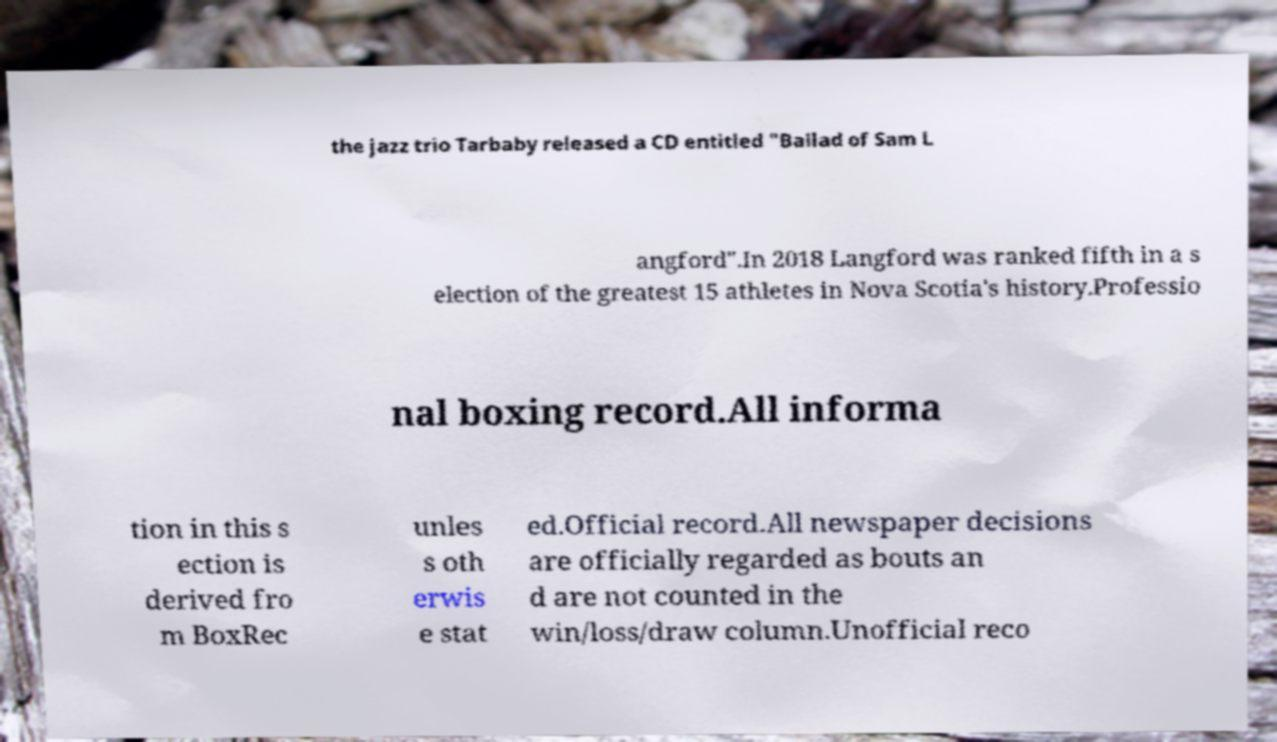For documentation purposes, I need the text within this image transcribed. Could you provide that? the jazz trio Tarbaby released a CD entitled "Ballad of Sam L angford".In 2018 Langford was ranked fifth in a s election of the greatest 15 athletes in Nova Scotia's history.Professio nal boxing record.All informa tion in this s ection is derived fro m BoxRec unles s oth erwis e stat ed.Official record.All newspaper decisions are officially regarded as bouts an d are not counted in the win/loss/draw column.Unofficial reco 